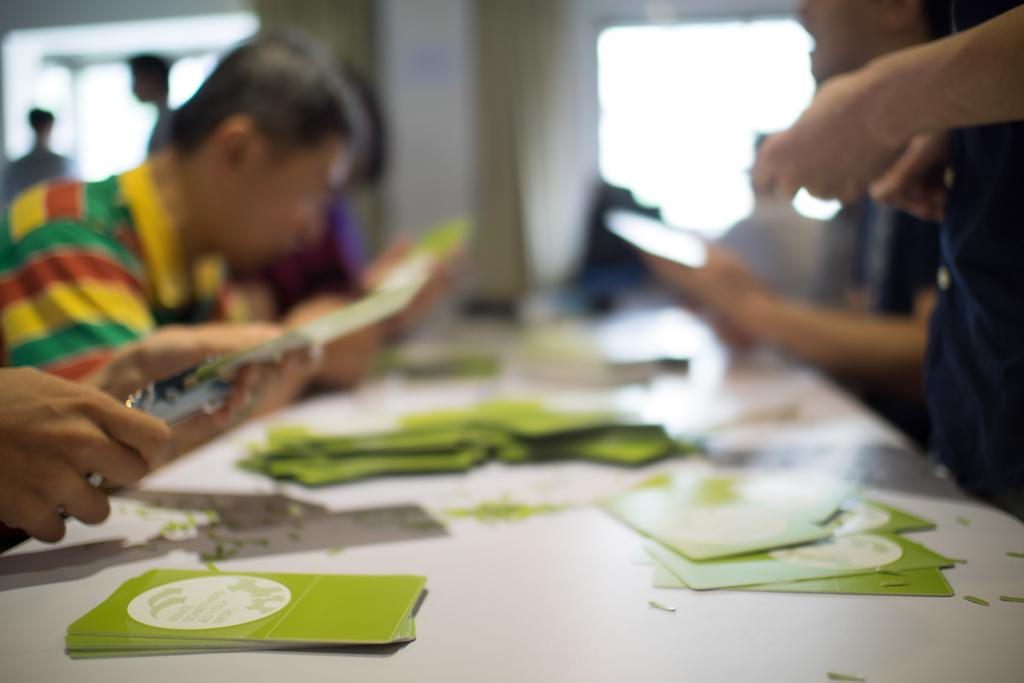What can be seen in the image involving multiple individuals? There is a group of people in the image. What is on the table in the image? There are papers and other things on the table in the image. Can you describe the background of the image? The background of the image is blurry. What type of beef is being prepared on the tub in the image? There is no tub or beef present in the image. What action are the people in the image performing? The provided facts do not specify any actions being performed by the people in the image. 